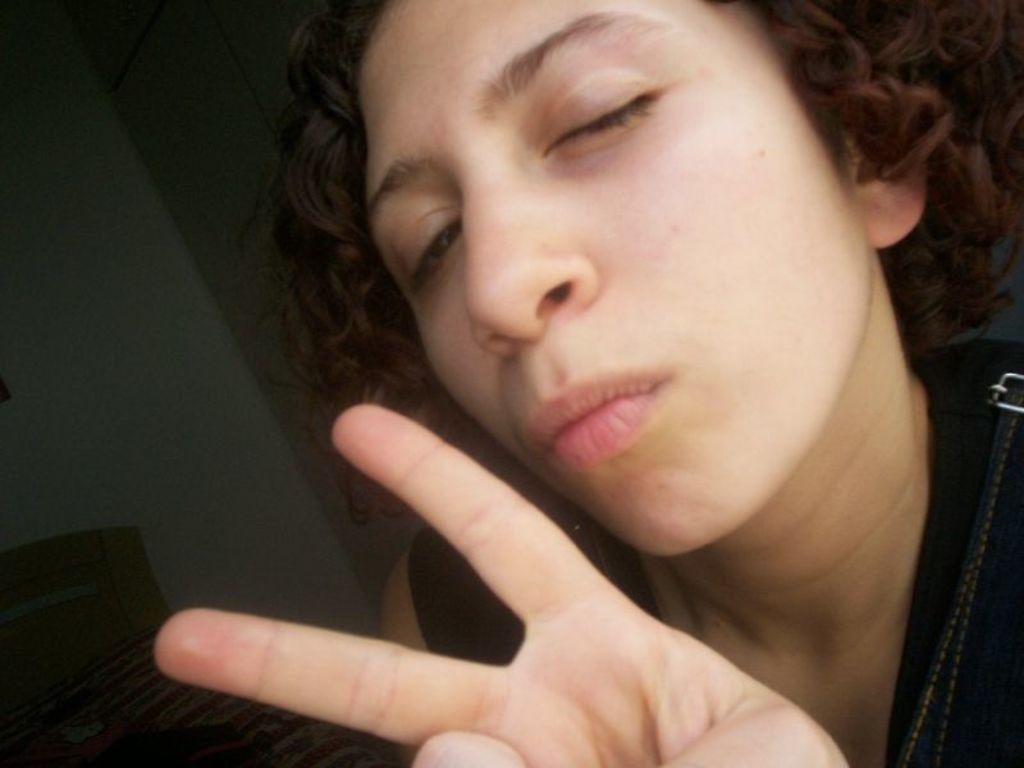Who is present in the image? There is a person in the image. What is the person wearing? The person is wearing a black dress. What is the person doing in the image? The person is in a giving pose for the picture. What can be seen in the background of the image? There is a bed and a wall in the background of the image. Can you see the person's dad in the image? There is no mention of a dad or any other family members in the image. What type of cemetery can be seen in the background of the image? There is no cemetery present in the image; it features a person, a black dress, a giving pose, a bed, and a wall in the background. 